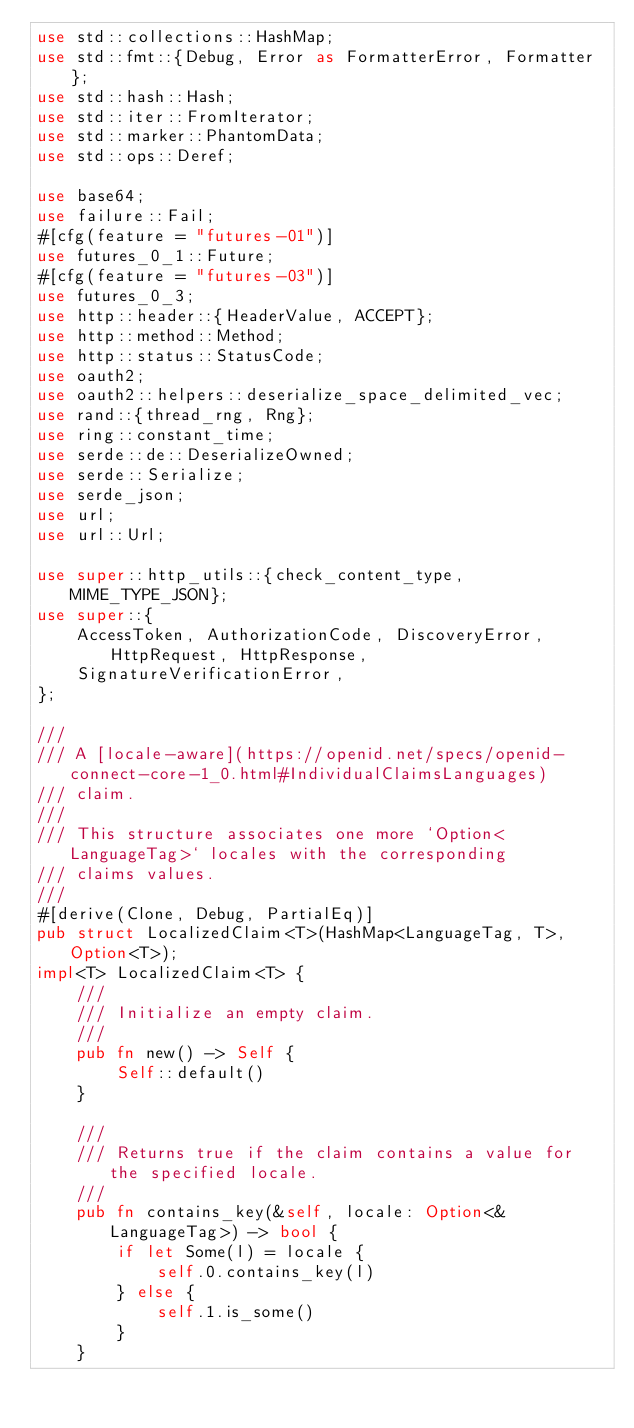Convert code to text. <code><loc_0><loc_0><loc_500><loc_500><_Rust_>use std::collections::HashMap;
use std::fmt::{Debug, Error as FormatterError, Formatter};
use std::hash::Hash;
use std::iter::FromIterator;
use std::marker::PhantomData;
use std::ops::Deref;

use base64;
use failure::Fail;
#[cfg(feature = "futures-01")]
use futures_0_1::Future;
#[cfg(feature = "futures-03")]
use futures_0_3;
use http::header::{HeaderValue, ACCEPT};
use http::method::Method;
use http::status::StatusCode;
use oauth2;
use oauth2::helpers::deserialize_space_delimited_vec;
use rand::{thread_rng, Rng};
use ring::constant_time;
use serde::de::DeserializeOwned;
use serde::Serialize;
use serde_json;
use url;
use url::Url;

use super::http_utils::{check_content_type, MIME_TYPE_JSON};
use super::{
    AccessToken, AuthorizationCode, DiscoveryError, HttpRequest, HttpResponse,
    SignatureVerificationError,
};

///
/// A [locale-aware](https://openid.net/specs/openid-connect-core-1_0.html#IndividualClaimsLanguages)
/// claim.
///
/// This structure associates one more `Option<LanguageTag>` locales with the corresponding
/// claims values.
///
#[derive(Clone, Debug, PartialEq)]
pub struct LocalizedClaim<T>(HashMap<LanguageTag, T>, Option<T>);
impl<T> LocalizedClaim<T> {
    ///
    /// Initialize an empty claim.
    ///
    pub fn new() -> Self {
        Self::default()
    }

    ///
    /// Returns true if the claim contains a value for the specified locale.
    ///
    pub fn contains_key(&self, locale: Option<&LanguageTag>) -> bool {
        if let Some(l) = locale {
            self.0.contains_key(l)
        } else {
            self.1.is_some()
        }
    }
</code> 